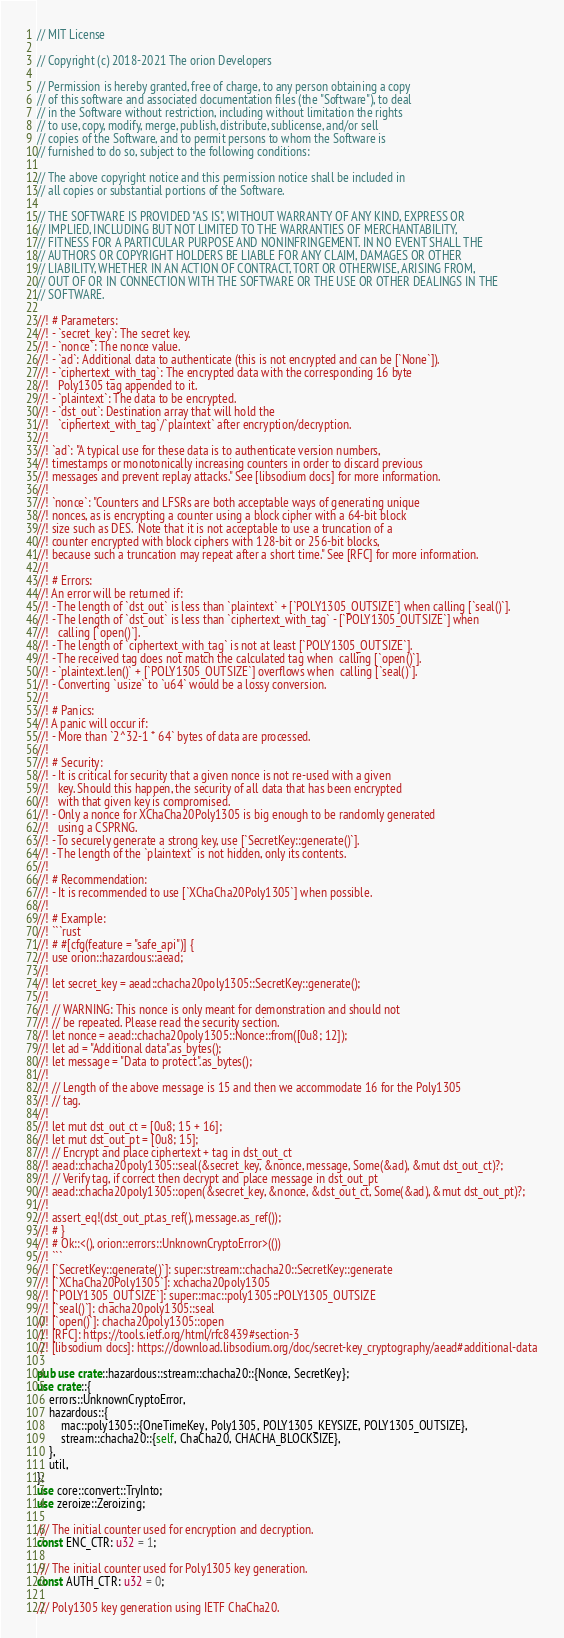<code> <loc_0><loc_0><loc_500><loc_500><_Rust_>// MIT License

// Copyright (c) 2018-2021 The orion Developers

// Permission is hereby granted, free of charge, to any person obtaining a copy
// of this software and associated documentation files (the "Software"), to deal
// in the Software without restriction, including without limitation the rights
// to use, copy, modify, merge, publish, distribute, sublicense, and/or sell
// copies of the Software, and to permit persons to whom the Software is
// furnished to do so, subject to the following conditions:

// The above copyright notice and this permission notice shall be included in
// all copies or substantial portions of the Software.

// THE SOFTWARE IS PROVIDED "AS IS", WITHOUT WARRANTY OF ANY KIND, EXPRESS OR
// IMPLIED, INCLUDING BUT NOT LIMITED TO THE WARRANTIES OF MERCHANTABILITY,
// FITNESS FOR A PARTICULAR PURPOSE AND NONINFRINGEMENT. IN NO EVENT SHALL THE
// AUTHORS OR COPYRIGHT HOLDERS BE LIABLE FOR ANY CLAIM, DAMAGES OR OTHER
// LIABILITY, WHETHER IN AN ACTION OF CONTRACT, TORT OR OTHERWISE, ARISING FROM,
// OUT OF OR IN CONNECTION WITH THE SOFTWARE OR THE USE OR OTHER DEALINGS IN THE
// SOFTWARE.

//! # Parameters:
//! - `secret_key`: The secret key.
//! - `nonce`: The nonce value.
//! - `ad`: Additional data to authenticate (this is not encrypted and can be [`None`]).
//! - `ciphertext_with_tag`: The encrypted data with the corresponding 16 byte
//!   Poly1305 tag appended to it.
//! - `plaintext`: The data to be encrypted.
//! - `dst_out`: Destination array that will hold the
//!   `ciphertext_with_tag`/`plaintext` after encryption/decryption.
//!
//! `ad`: "A typical use for these data is to authenticate version numbers,
//! timestamps or monotonically increasing counters in order to discard previous
//! messages and prevent replay attacks." See [libsodium docs] for more information.
//!
//! `nonce`: "Counters and LFSRs are both acceptable ways of generating unique
//! nonces, as is encrypting a counter using a block cipher with a 64-bit block
//! size such as DES.  Note that it is not acceptable to use a truncation of a
//! counter encrypted with block ciphers with 128-bit or 256-bit blocks,
//! because such a truncation may repeat after a short time." See [RFC] for more information.
//!
//! # Errors:
//! An error will be returned if:
//! - The length of `dst_out` is less than `plaintext` + [`POLY1305_OUTSIZE`] when calling [`seal()`].
//! - The length of `dst_out` is less than `ciphertext_with_tag` - [`POLY1305_OUTSIZE`] when
//!   calling [`open()`].
//! - The length of `ciphertext_with_tag` is not at least [`POLY1305_OUTSIZE`].
//! - The received tag does not match the calculated tag when  calling [`open()`].
//! - `plaintext.len()` + [`POLY1305_OUTSIZE`] overflows when  calling [`seal()`].
//! - Converting `usize` to `u64` would be a lossy conversion.
//!
//! # Panics:
//! A panic will occur if:
//! - More than `2^32-1 * 64` bytes of data are processed.
//!
//! # Security:
//! - It is critical for security that a given nonce is not re-used with a given
//!   key. Should this happen, the security of all data that has been encrypted
//!   with that given key is compromised.
//! - Only a nonce for XChaCha20Poly1305 is big enough to be randomly generated
//!   using a CSPRNG.
//! - To securely generate a strong key, use [`SecretKey::generate()`].
//! - The length of the `plaintext` is not hidden, only its contents.
//!
//! # Recommendation:
//! - It is recommended to use [`XChaCha20Poly1305`] when possible.
//!
//! # Example:
//! ```rust
//! # #[cfg(feature = "safe_api")] {
//! use orion::hazardous::aead;
//!
//! let secret_key = aead::chacha20poly1305::SecretKey::generate();
//!
//! // WARNING: This nonce is only meant for demonstration and should not
//! // be repeated. Please read the security section.
//! let nonce = aead::chacha20poly1305::Nonce::from([0u8; 12]);
//! let ad = "Additional data".as_bytes();
//! let message = "Data to protect".as_bytes();
//!
//! // Length of the above message is 15 and then we accommodate 16 for the Poly1305
//! // tag.
//!
//! let mut dst_out_ct = [0u8; 15 + 16];
//! let mut dst_out_pt = [0u8; 15];
//! // Encrypt and place ciphertext + tag in dst_out_ct
//! aead::chacha20poly1305::seal(&secret_key, &nonce, message, Some(&ad), &mut dst_out_ct)?;
//! // Verify tag, if correct then decrypt and place message in dst_out_pt
//! aead::chacha20poly1305::open(&secret_key, &nonce, &dst_out_ct, Some(&ad), &mut dst_out_pt)?;
//!
//! assert_eq!(dst_out_pt.as_ref(), message.as_ref());
//! # }
//! # Ok::<(), orion::errors::UnknownCryptoError>(())
//! ```
//! [`SecretKey::generate()`]: super::stream::chacha20::SecretKey::generate
//! [`XChaCha20Poly1305`]: xchacha20poly1305
//! [`POLY1305_OUTSIZE`]: super::mac::poly1305::POLY1305_OUTSIZE
//! [`seal()`]: chacha20poly1305::seal
//! [`open()`]: chacha20poly1305::open
//! [RFC]: https://tools.ietf.org/html/rfc8439#section-3
//! [libsodium docs]: https://download.libsodium.org/doc/secret-key_cryptography/aead#additional-data

pub use crate::hazardous::stream::chacha20::{Nonce, SecretKey};
use crate::{
    errors::UnknownCryptoError,
    hazardous::{
        mac::poly1305::{OneTimeKey, Poly1305, POLY1305_KEYSIZE, POLY1305_OUTSIZE},
        stream::chacha20::{self, ChaCha20, CHACHA_BLOCKSIZE},
    },
    util,
};
use core::convert::TryInto;
use zeroize::Zeroizing;

/// The initial counter used for encryption and decryption.
const ENC_CTR: u32 = 1;

/// The initial counter used for Poly1305 key generation.
const AUTH_CTR: u32 = 0;

/// Poly1305 key generation using IETF ChaCha20.</code> 